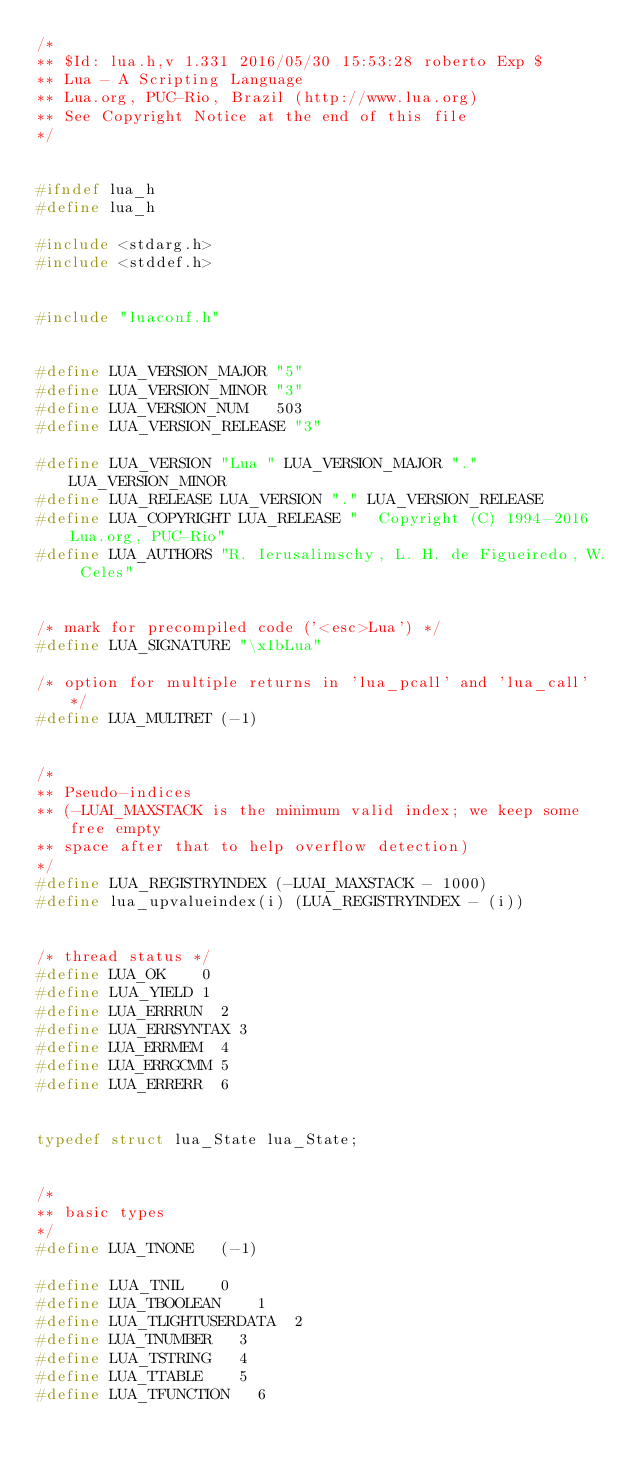Convert code to text. <code><loc_0><loc_0><loc_500><loc_500><_C_>/*
** $Id: lua.h,v 1.331 2016/05/30 15:53:28 roberto Exp $
** Lua - A Scripting Language
** Lua.org, PUC-Rio, Brazil (http://www.lua.org)
** See Copyright Notice at the end of this file
*/


#ifndef lua_h
#define lua_h

#include <stdarg.h>
#include <stddef.h>


#include "luaconf.h"


#define LUA_VERSION_MAJOR	"5"
#define LUA_VERSION_MINOR	"3"
#define LUA_VERSION_NUM		503
#define LUA_VERSION_RELEASE	"3"

#define LUA_VERSION	"Lua " LUA_VERSION_MAJOR "." LUA_VERSION_MINOR
#define LUA_RELEASE	LUA_VERSION "." LUA_VERSION_RELEASE
#define LUA_COPYRIGHT	LUA_RELEASE "  Copyright (C) 1994-2016 Lua.org, PUC-Rio"
#define LUA_AUTHORS	"R. Ierusalimschy, L. H. de Figueiredo, W. Celes"


/* mark for precompiled code ('<esc>Lua') */
#define LUA_SIGNATURE	"\x1bLua"

/* option for multiple returns in 'lua_pcall' and 'lua_call' */
#define LUA_MULTRET	(-1)


/*
** Pseudo-indices
** (-LUAI_MAXSTACK is the minimum valid index; we keep some free empty
** space after that to help overflow detection)
*/
#define LUA_REGISTRYINDEX	(-LUAI_MAXSTACK - 1000)
#define lua_upvalueindex(i)	(LUA_REGISTRYINDEX - (i))


/* thread status */
#define LUA_OK		0
#define LUA_YIELD	1
#define LUA_ERRRUN	2
#define LUA_ERRSYNTAX	3
#define LUA_ERRMEM	4
#define LUA_ERRGCMM	5
#define LUA_ERRERR	6


typedef struct lua_State lua_State;


/*
** basic types
*/
#define LUA_TNONE		(-1)

#define LUA_TNIL		0
#define LUA_TBOOLEAN		1
#define LUA_TLIGHTUSERDATA	2
#define LUA_TNUMBER		3
#define LUA_TSTRING		4
#define LUA_TTABLE		5
#define LUA_TFUNCTION		6</code> 